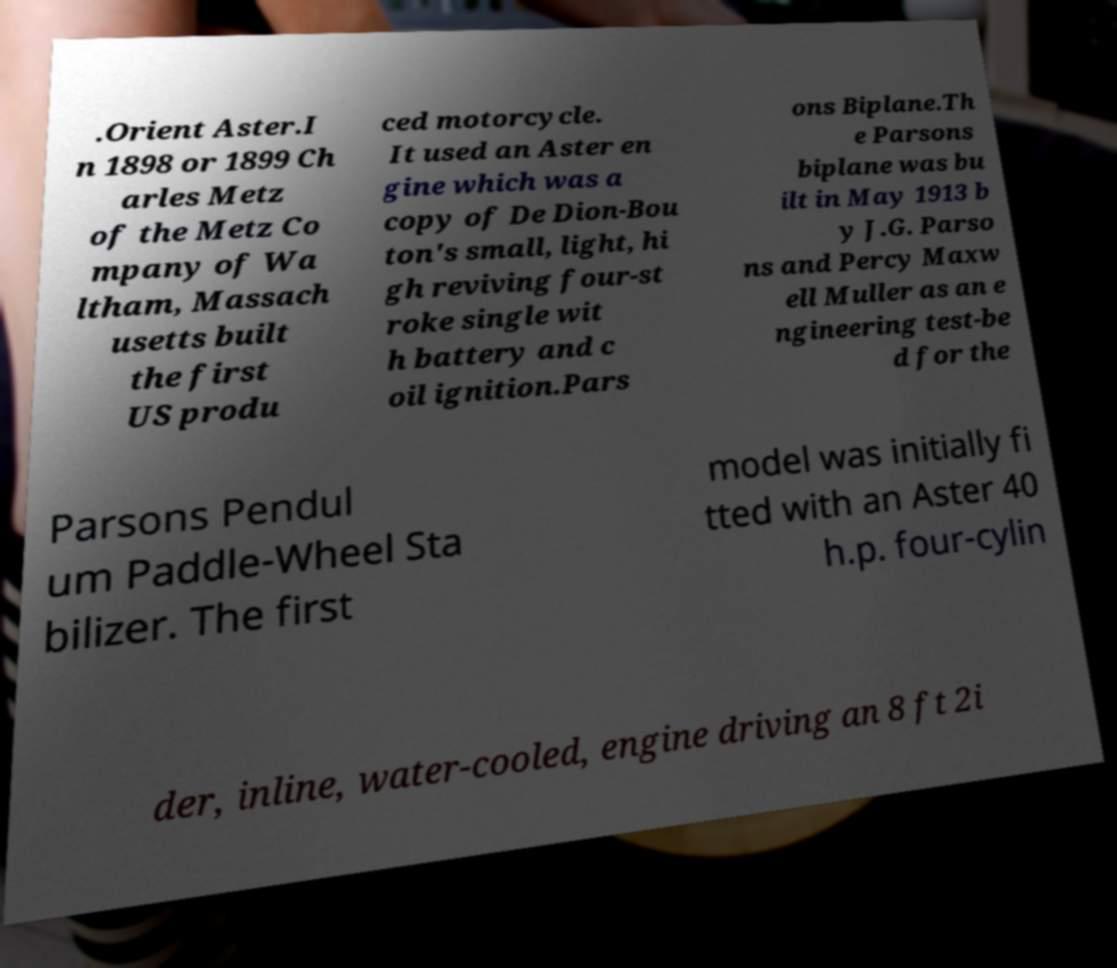There's text embedded in this image that I need extracted. Can you transcribe it verbatim? .Orient Aster.I n 1898 or 1899 Ch arles Metz of the Metz Co mpany of Wa ltham, Massach usetts built the first US produ ced motorcycle. It used an Aster en gine which was a copy of De Dion-Bou ton's small, light, hi gh reviving four-st roke single wit h battery and c oil ignition.Pars ons Biplane.Th e Parsons biplane was bu ilt in May 1913 b y J.G. Parso ns and Percy Maxw ell Muller as an e ngineering test-be d for the Parsons Pendul um Paddle-Wheel Sta bilizer. The first model was initially fi tted with an Aster 40 h.p. four-cylin der, inline, water-cooled, engine driving an 8 ft 2i 